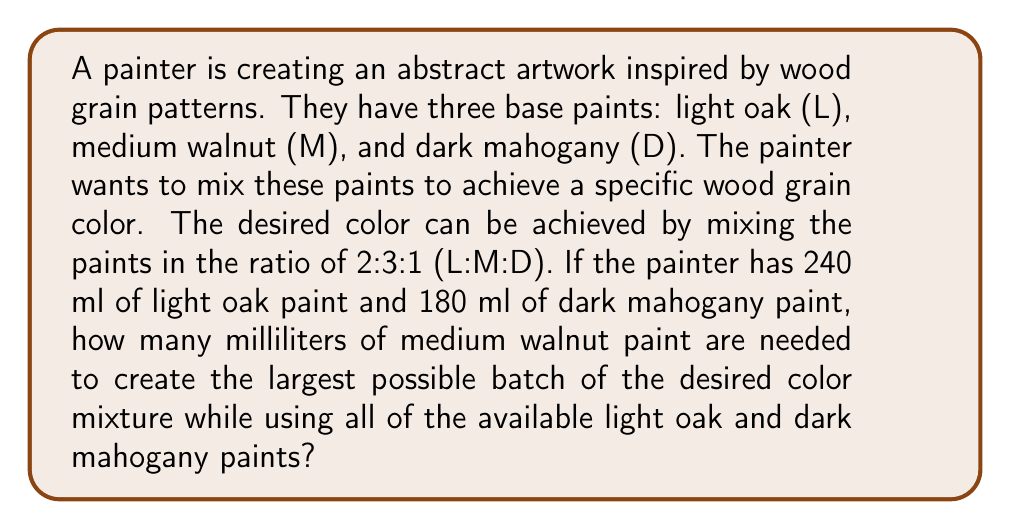Help me with this question. To solve this problem, we'll use the concept of limiting reagents from chemical reactions, applying it to paint mixing ratios.

1. Let's define our variables:
   $x$ = number of units of the desired mixture

2. Given ratio of L:M:D is 2:3:1, we can write:
   Light oak: $2x$
   Medium walnut: $3x$
   Dark mahogany: $x$

3. We know the available amounts:
   Light oak: 240 ml
   Dark mahogany: 180 ml

4. Set up equations based on the available amounts:
   $$2x = 240$$
   $$x = 180$$

5. Solve these equations:
   From the first equation: $x = 120$
   From the second equation: $x = 180$

6. The limiting factor is light oak, as it gives the smaller value of $x$. So, $x = 120$.

7. Calculate the amount of medium walnut needed:
   Medium walnut = $3x = 3 * 120 = 360$ ml

Therefore, 360 ml of medium walnut paint is needed to create the largest possible batch of the desired color mixture while using all of the available light oak and dark mahogany paints.
Answer: 360 ml of medium walnut paint 